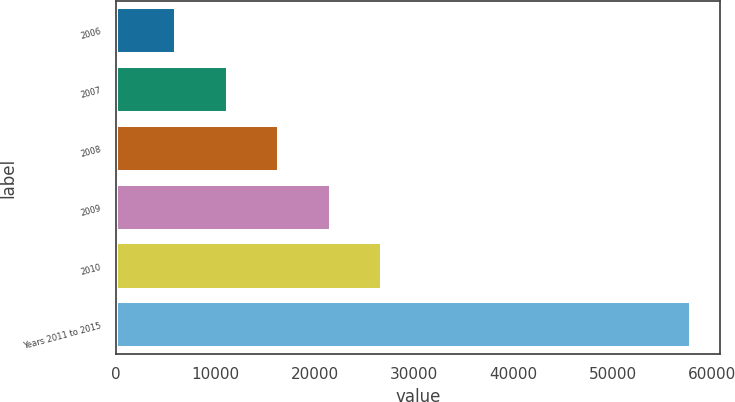Convert chart to OTSL. <chart><loc_0><loc_0><loc_500><loc_500><bar_chart><fcel>2006<fcel>2007<fcel>2008<fcel>2009<fcel>2010<fcel>Years 2011 to 2015<nl><fcel>6073<fcel>11258.9<fcel>16444.8<fcel>21630.7<fcel>26816.6<fcel>57932<nl></chart> 